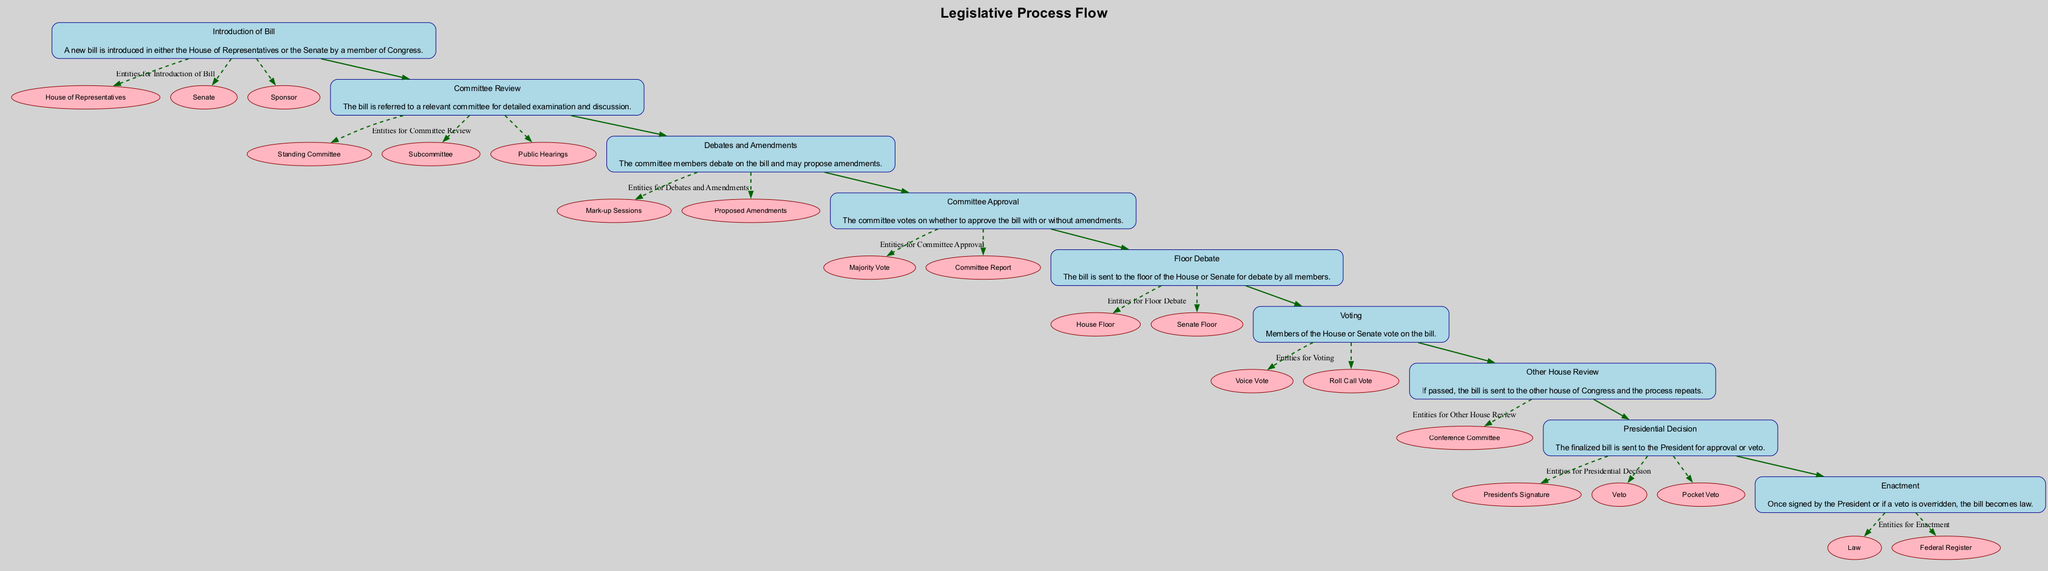What is the first step in the legislative process? The first step in the legislative process is the "Introduction of Bill," where a new bill is introduced by a member of Congress in either the House of Representatives or the Senate.
Answer: Introduction of Bill How many blocks are in the diagram? The diagram contains a total of nine distinct blocks representing different stages of the legislative process.
Answer: 9 What happens after Committee Review? After the "Committee Review," the process leads to "Debates and Amendments," where committee members debate the bill and propose amendments.
Answer: Debates and Amendments Which entity is involved in the Presidential Decision block? The entities involved in the "Presidential Decision" block include the "President's Signature," "Veto," and "Pocket Veto."
Answer: President's Signature, Veto, Pocket Veto In which block does the Committee vote occur? The "Committee Approval" block is where the committee votes on whether to approve the bill with or without amendments.
Answer: Committee Approval What is indicated by the dashed lines in the diagram? The dashed lines in the diagram indicate the relationships of entities to their respective blocks, illustrating the entities associated with each legislative step.
Answer: Relationships of entities What is the final outcome if the bill is enacted? If the bill is enacted, it becomes law and is recorded in the Federal Register, marking its approval after the necessary processes.
Answer: Law Which block follows the Floor Debate? The block that follows "Floor Debate" is "Voting," where members of the House or Senate cast their votes on the bill.
Answer: Voting What is the role of the Conference Committee in the process? The "Conference Committee" is involved in the "Other House Review" block, where it aids in reconciling differences between the House and Senate versions of the bill.
Answer: Conference Committee 